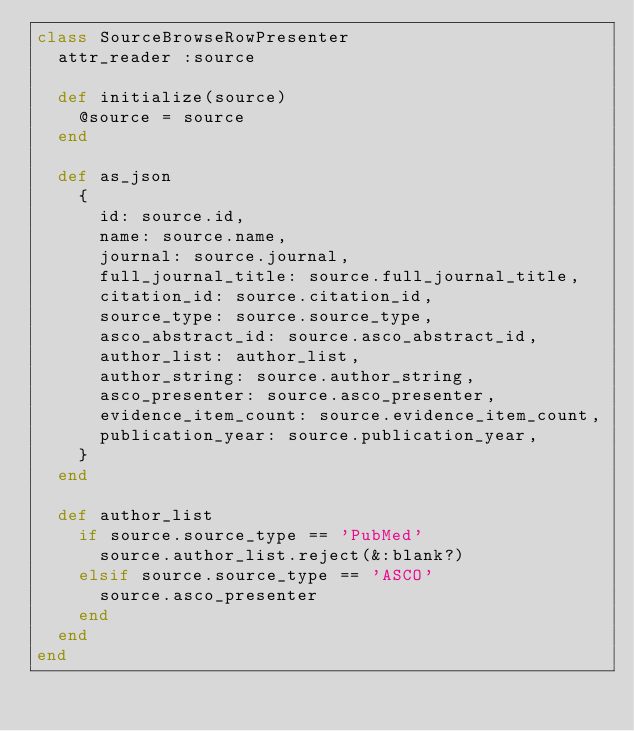<code> <loc_0><loc_0><loc_500><loc_500><_Ruby_>class SourceBrowseRowPresenter
  attr_reader :source

  def initialize(source)
    @source = source
  end

  def as_json
    {
      id: source.id,
      name: source.name,
      journal: source.journal,
      full_journal_title: source.full_journal_title,
      citation_id: source.citation_id,
      source_type: source.source_type,
      asco_abstract_id: source.asco_abstract_id,
      author_list: author_list,
      author_string: source.author_string,
      asco_presenter: source.asco_presenter,
      evidence_item_count: source.evidence_item_count,
      publication_year: source.publication_year,
    }
  end

  def author_list
    if source.source_type == 'PubMed'
      source.author_list.reject(&:blank?)
    elsif source.source_type == 'ASCO'
      source.asco_presenter
    end
  end
end
</code> 